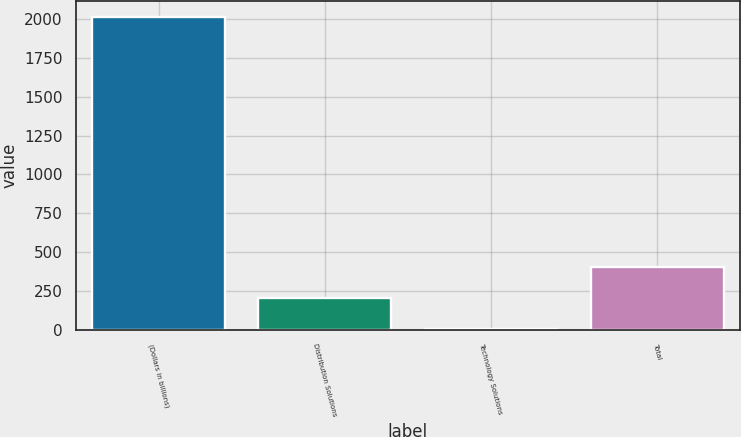Convert chart to OTSL. <chart><loc_0><loc_0><loc_500><loc_500><bar_chart><fcel>(Dollars in billions)<fcel>Distribution Solutions<fcel>Technology Solutions<fcel>Total<nl><fcel>2015<fcel>203.3<fcel>2<fcel>404.6<nl></chart> 